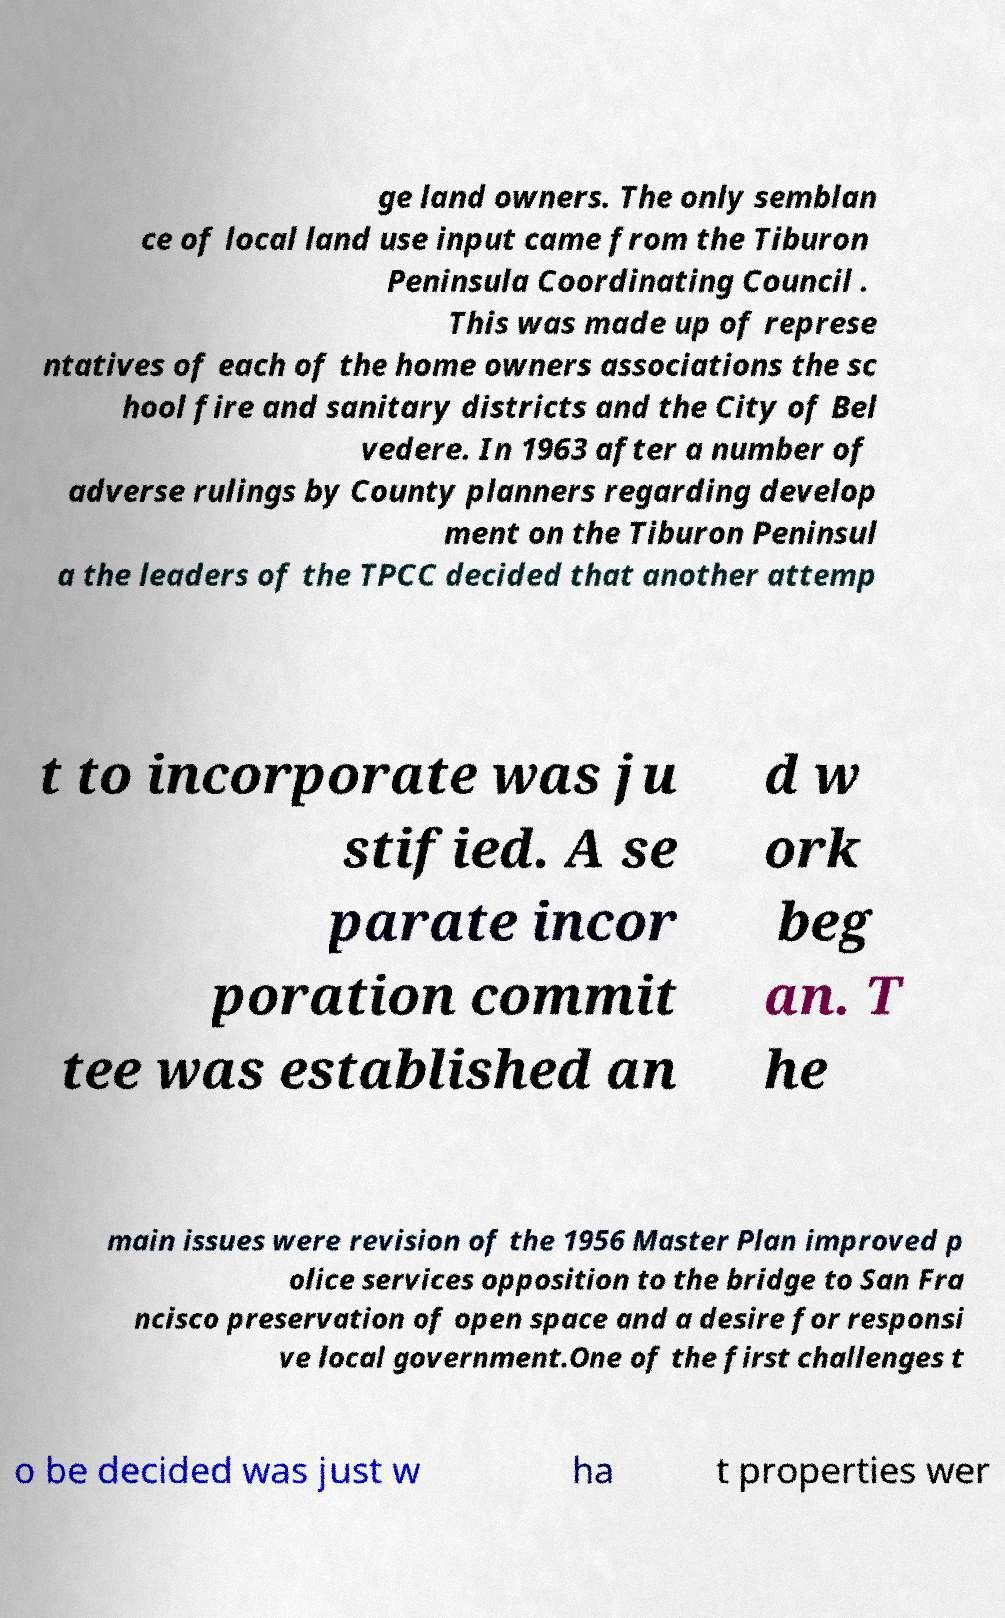What messages or text are displayed in this image? I need them in a readable, typed format. ge land owners. The only semblan ce of local land use input came from the Tiburon Peninsula Coordinating Council . This was made up of represe ntatives of each of the home owners associations the sc hool fire and sanitary districts and the City of Bel vedere. In 1963 after a number of adverse rulings by County planners regarding develop ment on the Tiburon Peninsul a the leaders of the TPCC decided that another attemp t to incorporate was ju stified. A se parate incor poration commit tee was established an d w ork beg an. T he main issues were revision of the 1956 Master Plan improved p olice services opposition to the bridge to San Fra ncisco preservation of open space and a desire for responsi ve local government.One of the first challenges t o be decided was just w ha t properties wer 